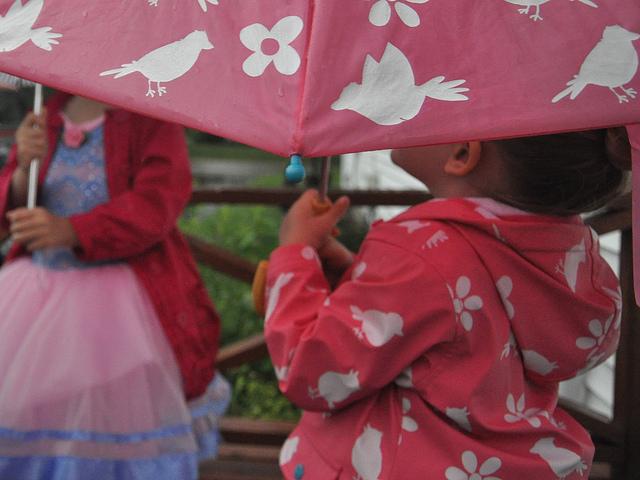Do the girls' jacket and umbrella match?
Be succinct. Yes. What is the child holding?
Quick response, please. Umbrella. How many children are in the picture?
Be succinct. 2. 